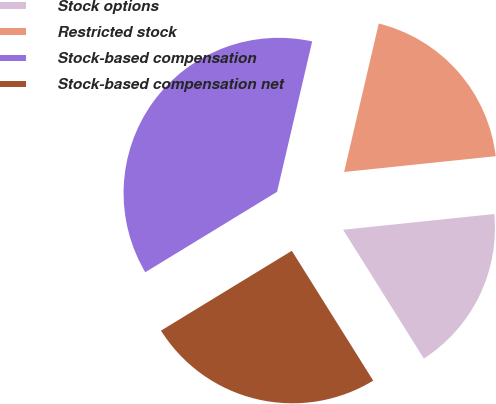Convert chart. <chart><loc_0><loc_0><loc_500><loc_500><pie_chart><fcel>Stock options<fcel>Restricted stock<fcel>Stock-based compensation<fcel>Stock-based compensation net<nl><fcel>17.74%<fcel>19.7%<fcel>37.37%<fcel>25.19%<nl></chart> 